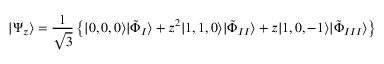<formula> <loc_0><loc_0><loc_500><loc_500>| \Psi _ { z } \rangle = \frac { 1 } { \sqrt { 3 } } \left \{ | 0 , 0 , 0 \rangle | \tilde { \Phi } _ { I } \rangle + z ^ { 2 } | 1 , 1 , 0 \rangle | \tilde { \Phi } _ { I I } \rangle + z | 1 , 0 , - 1 \rangle | \tilde { \Phi } _ { I I I } \rangle \right \}</formula> 